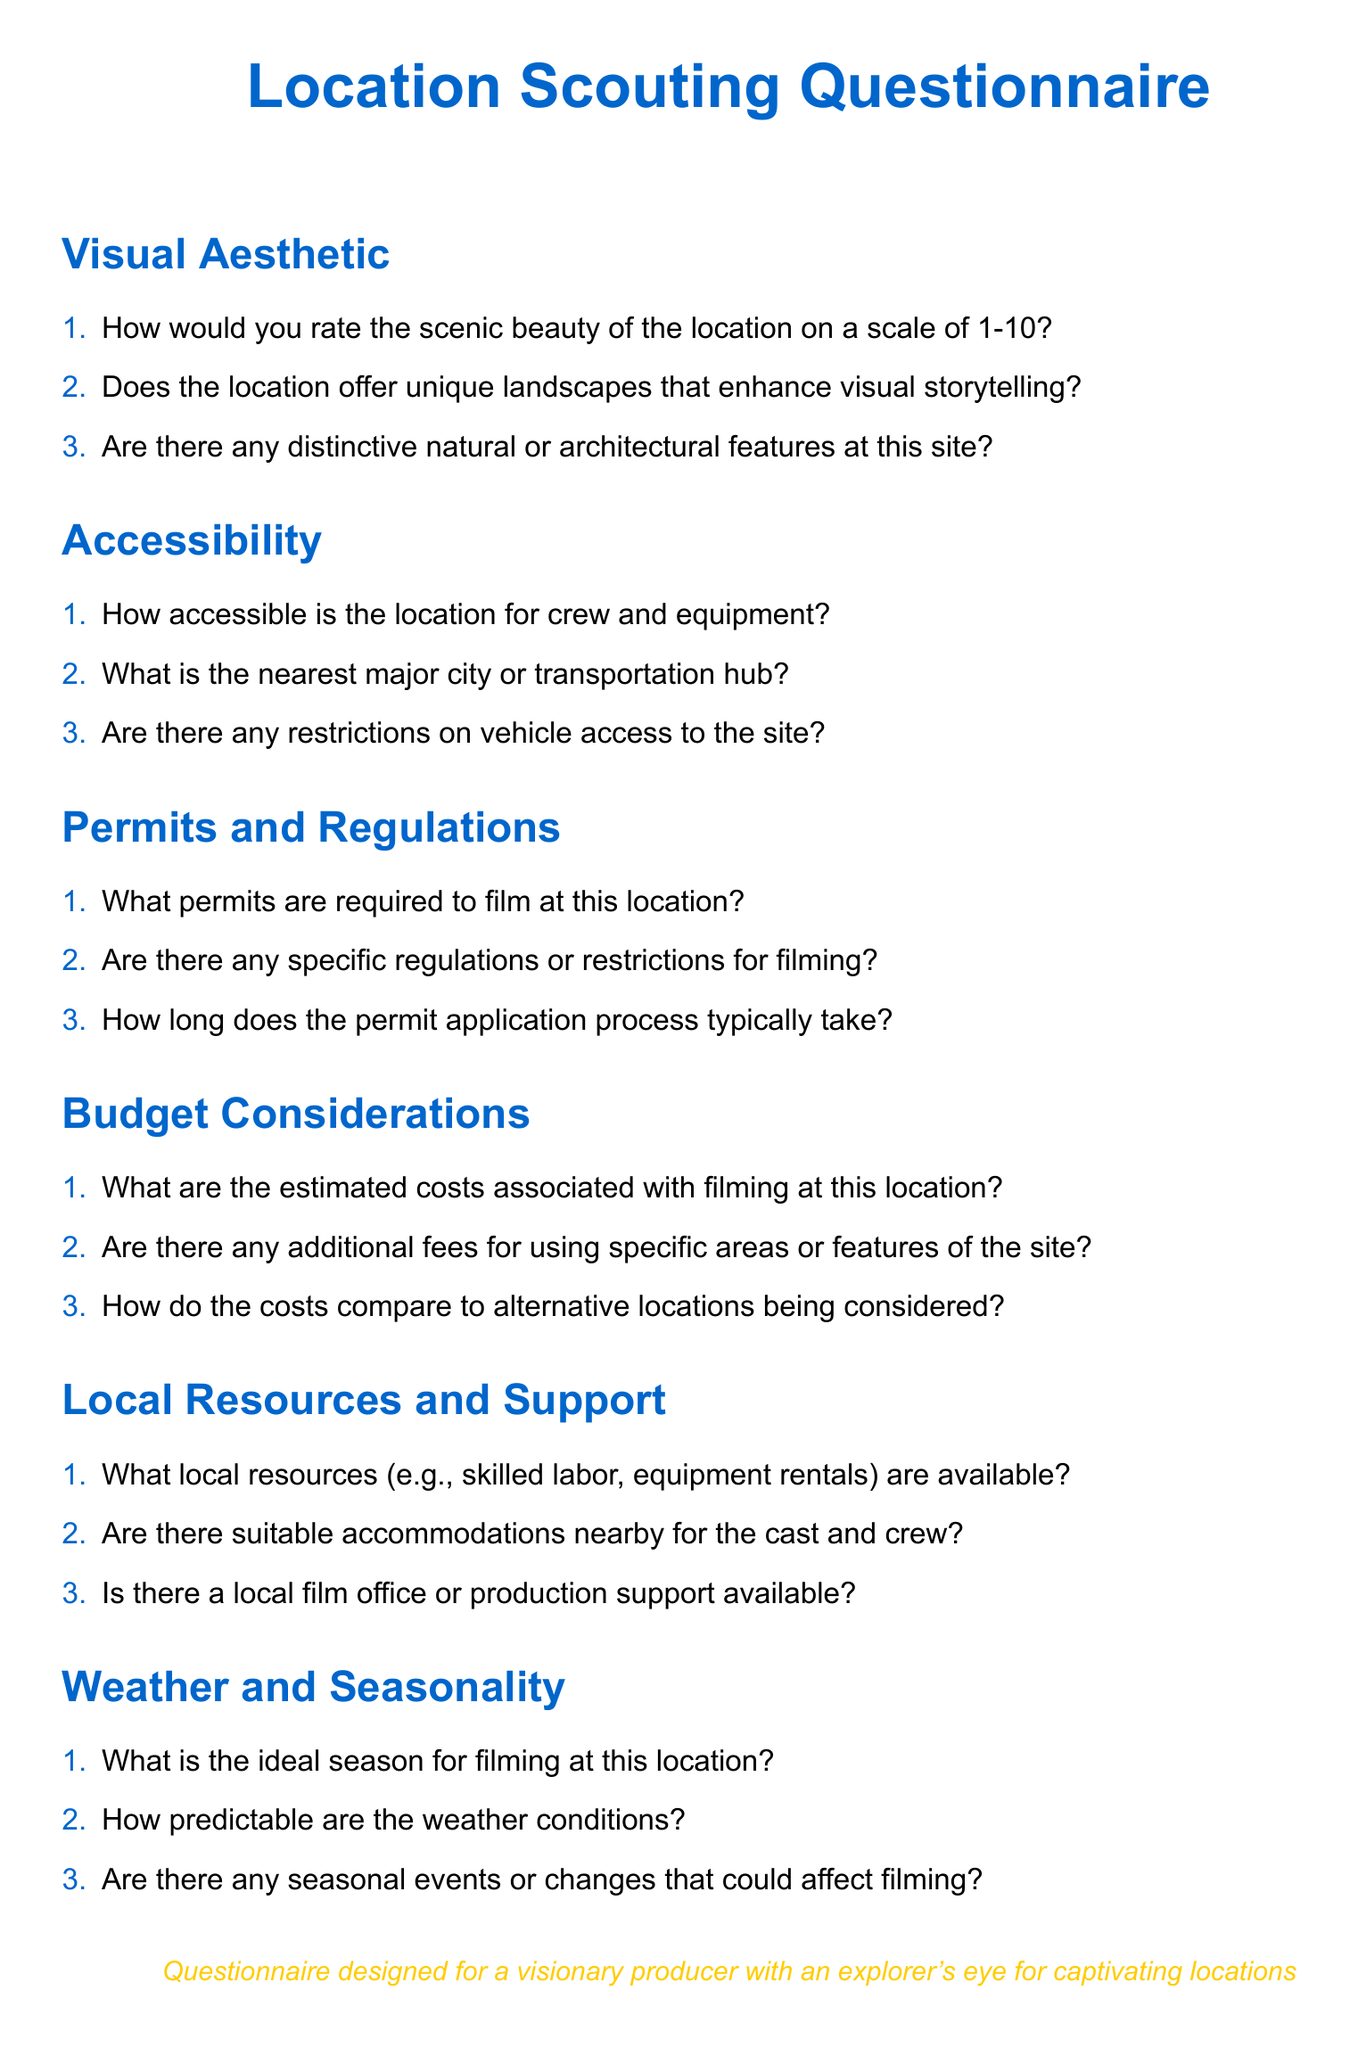What is the main color used for headings? The document specifies a main color defined as RGB(0,102,204) for headings, which corresponds to a shade of blue.
Answer: blue How many sections are in the questionnaire? The document features six main sections, each addressing different aspects of location scouting.
Answer: 6 What is the purpose of the questionnaire as noted in the document? The document includes a note at the end that describes the purpose of the questionnaire for a specific audience, which is a visionary producer.
Answer: Captivating locations What is the first criterion evaluated in the questionnaire? The first section of the questionnaire is labeled "Visual Aesthetic," addressing scenic beauty and unique landscapes.
Answer: Visual Aesthetic What is the ideal response scale for rating scenic beauty? The first question under Visual Aesthetic asks for a rating on a scale from 1 to 10.
Answer: 1-10 What type of local resources are mentioned in the questionnaire? The document questions the availability of local resources, specifically mentioning skilled labor and equipment rentals.
Answer: skilled labor, equipment rentals How predictable are the weather conditions according to the document's questions? The document asks for predictability of weather conditions, implying that it's a factor in location scouting.
Answer: Predictability What color is used for the text note at the bottom of the document? The note at the bottom uses a second color defined as RGB(255,204,0) which is a shade of yellow for emphasis.
Answer: yellow What is the last section titled in the questionnaire? The last section is titled "Weather and Seasonality," covering seasonal factors affecting filming.
Answer: Weather and Seasonality 